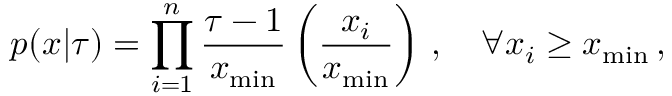Convert formula to latex. <formula><loc_0><loc_0><loc_500><loc_500>p ( x | \tau ) = \prod _ { i = 1 } ^ { n } \frac { \tau - 1 } { x _ { \min } } \left ( \frac { x _ { i } } { x _ { \min } } \right ) \, , \quad \forall x _ { i } \geq x _ { \min } \, ,</formula> 